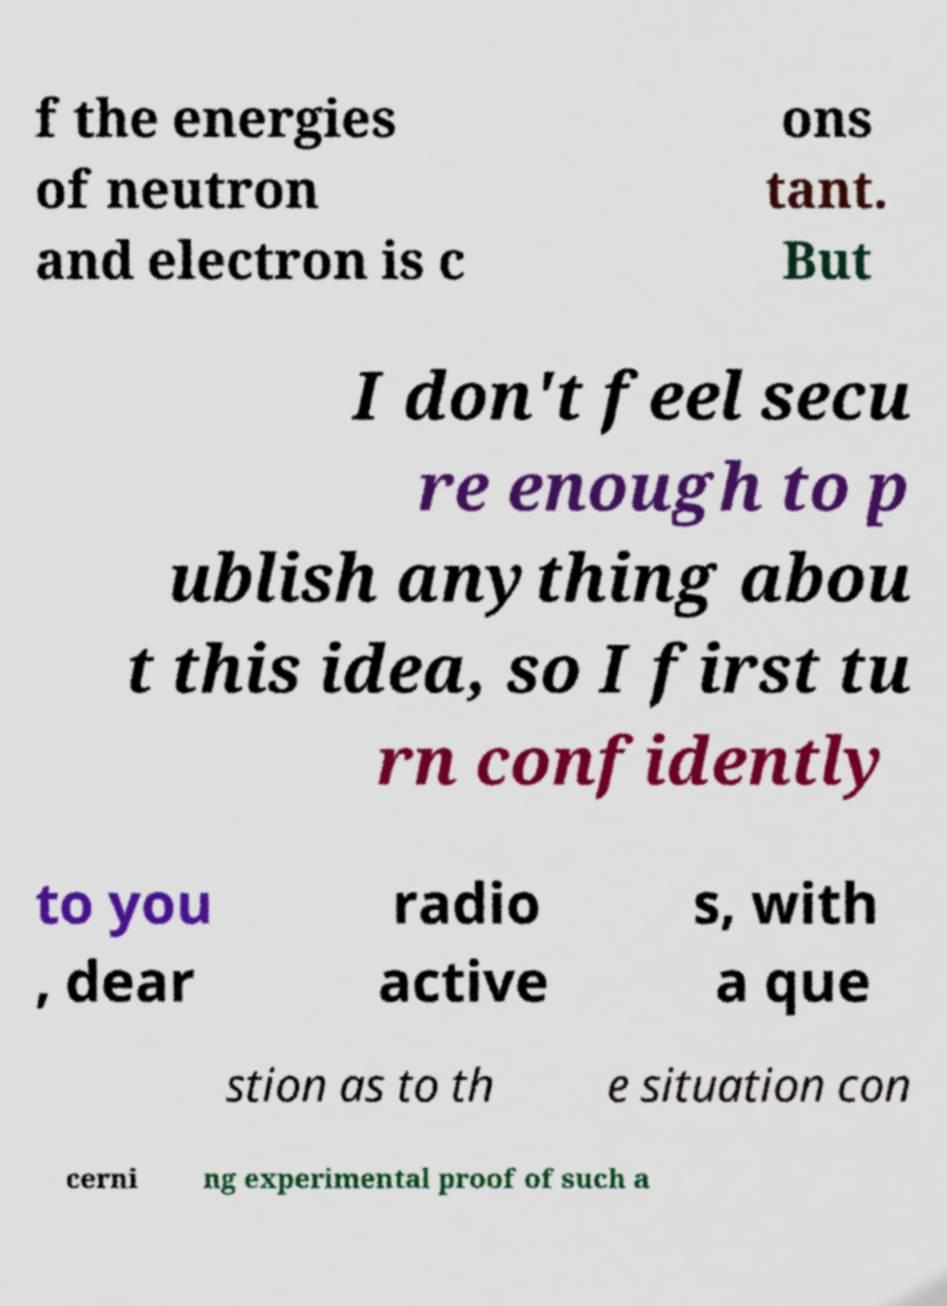For documentation purposes, I need the text within this image transcribed. Could you provide that? f the energies of neutron and electron is c ons tant. But I don't feel secu re enough to p ublish anything abou t this idea, so I first tu rn confidently to you , dear radio active s, with a que stion as to th e situation con cerni ng experimental proof of such a 